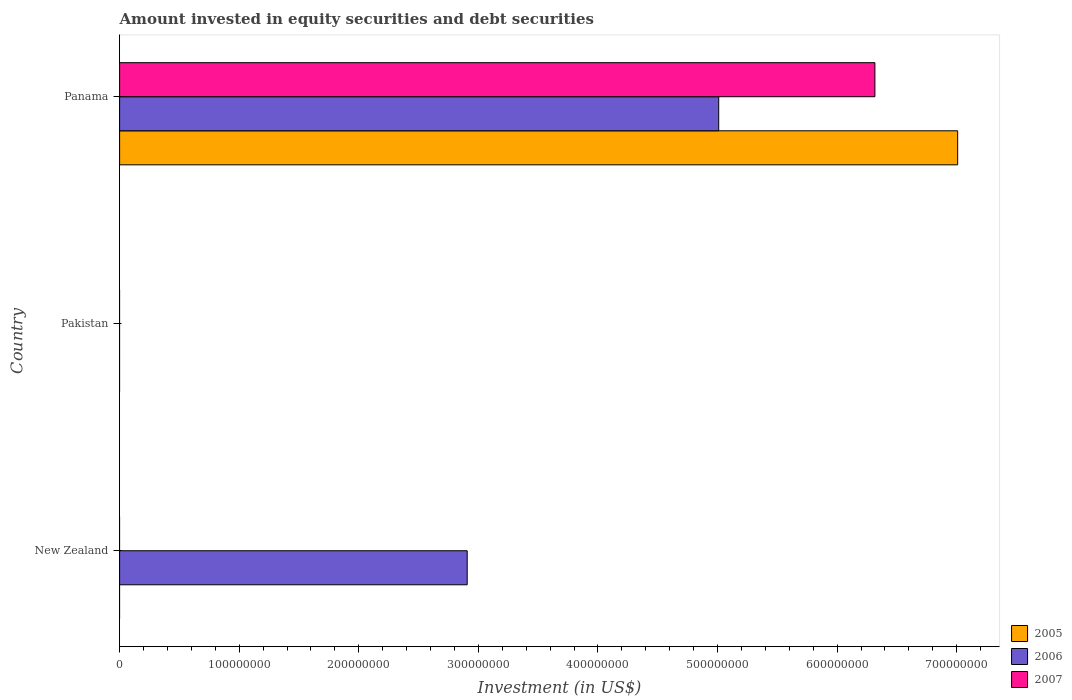Are the number of bars per tick equal to the number of legend labels?
Provide a short and direct response. No. What is the amount invested in equity securities and debt securities in 2005 in New Zealand?
Provide a succinct answer. 0. Across all countries, what is the maximum amount invested in equity securities and debt securities in 2005?
Provide a short and direct response. 7.01e+08. In which country was the amount invested in equity securities and debt securities in 2006 maximum?
Your answer should be very brief. Panama. What is the total amount invested in equity securities and debt securities in 2006 in the graph?
Give a very brief answer. 7.92e+08. What is the difference between the amount invested in equity securities and debt securities in 2006 in New Zealand and that in Panama?
Offer a terse response. -2.10e+08. What is the difference between the amount invested in equity securities and debt securities in 2006 in Panama and the amount invested in equity securities and debt securities in 2005 in Pakistan?
Your answer should be compact. 5.01e+08. What is the average amount invested in equity securities and debt securities in 2007 per country?
Ensure brevity in your answer.  2.11e+08. What is the difference between the amount invested in equity securities and debt securities in 2007 and amount invested in equity securities and debt securities in 2006 in Panama?
Offer a very short reply. 1.31e+08. What is the ratio of the amount invested in equity securities and debt securities in 2006 in New Zealand to that in Panama?
Give a very brief answer. 0.58. What is the difference between the highest and the lowest amount invested in equity securities and debt securities in 2007?
Offer a very short reply. 6.32e+08. In how many countries, is the amount invested in equity securities and debt securities in 2006 greater than the average amount invested in equity securities and debt securities in 2006 taken over all countries?
Ensure brevity in your answer.  2. How many bars are there?
Your response must be concise. 4. What is the difference between two consecutive major ticks on the X-axis?
Your answer should be compact. 1.00e+08. Are the values on the major ticks of X-axis written in scientific E-notation?
Provide a succinct answer. No. Where does the legend appear in the graph?
Your answer should be very brief. Bottom right. What is the title of the graph?
Provide a succinct answer. Amount invested in equity securities and debt securities. What is the label or title of the X-axis?
Make the answer very short. Investment (in US$). What is the Investment (in US$) in 2005 in New Zealand?
Keep it short and to the point. 0. What is the Investment (in US$) in 2006 in New Zealand?
Your answer should be very brief. 2.91e+08. What is the Investment (in US$) in 2007 in New Zealand?
Ensure brevity in your answer.  0. What is the Investment (in US$) of 2007 in Pakistan?
Keep it short and to the point. 0. What is the Investment (in US$) of 2005 in Panama?
Ensure brevity in your answer.  7.01e+08. What is the Investment (in US$) in 2006 in Panama?
Offer a very short reply. 5.01e+08. What is the Investment (in US$) in 2007 in Panama?
Make the answer very short. 6.32e+08. Across all countries, what is the maximum Investment (in US$) in 2005?
Give a very brief answer. 7.01e+08. Across all countries, what is the maximum Investment (in US$) in 2006?
Provide a short and direct response. 5.01e+08. Across all countries, what is the maximum Investment (in US$) of 2007?
Your answer should be very brief. 6.32e+08. Across all countries, what is the minimum Investment (in US$) in 2007?
Your answer should be very brief. 0. What is the total Investment (in US$) in 2005 in the graph?
Provide a short and direct response. 7.01e+08. What is the total Investment (in US$) in 2006 in the graph?
Give a very brief answer. 7.92e+08. What is the total Investment (in US$) of 2007 in the graph?
Give a very brief answer. 6.32e+08. What is the difference between the Investment (in US$) in 2006 in New Zealand and that in Panama?
Offer a very short reply. -2.10e+08. What is the difference between the Investment (in US$) of 2006 in New Zealand and the Investment (in US$) of 2007 in Panama?
Your response must be concise. -3.41e+08. What is the average Investment (in US$) in 2005 per country?
Provide a short and direct response. 2.34e+08. What is the average Investment (in US$) in 2006 per country?
Give a very brief answer. 2.64e+08. What is the average Investment (in US$) of 2007 per country?
Offer a very short reply. 2.11e+08. What is the difference between the Investment (in US$) in 2005 and Investment (in US$) in 2006 in Panama?
Ensure brevity in your answer.  2.00e+08. What is the difference between the Investment (in US$) in 2005 and Investment (in US$) in 2007 in Panama?
Provide a short and direct response. 6.92e+07. What is the difference between the Investment (in US$) in 2006 and Investment (in US$) in 2007 in Panama?
Your answer should be compact. -1.31e+08. What is the ratio of the Investment (in US$) of 2006 in New Zealand to that in Panama?
Offer a very short reply. 0.58. What is the difference between the highest and the lowest Investment (in US$) in 2005?
Make the answer very short. 7.01e+08. What is the difference between the highest and the lowest Investment (in US$) in 2006?
Give a very brief answer. 5.01e+08. What is the difference between the highest and the lowest Investment (in US$) in 2007?
Your answer should be very brief. 6.32e+08. 